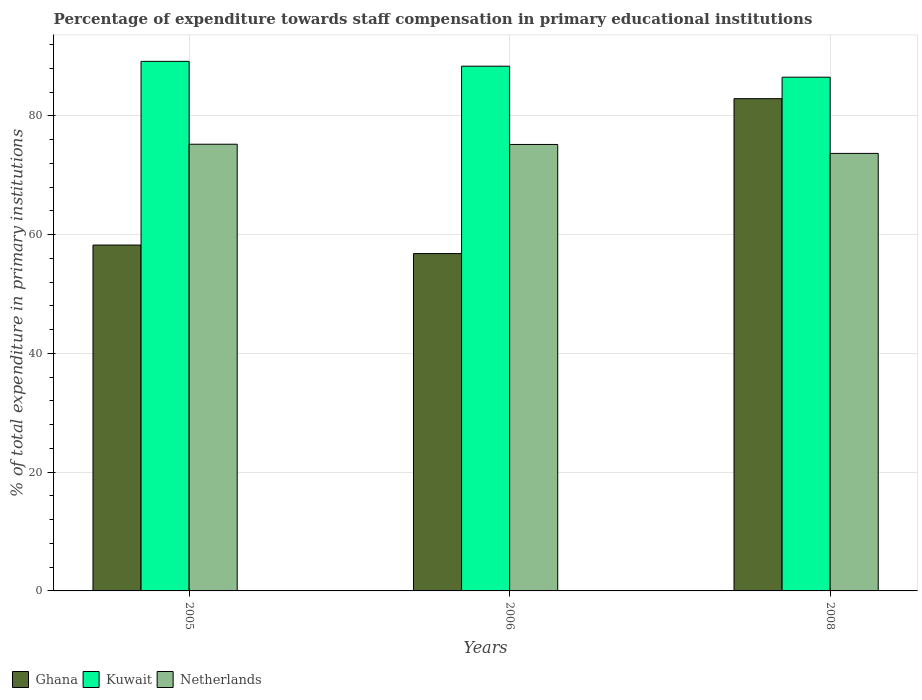How many different coloured bars are there?
Provide a succinct answer. 3. How many groups of bars are there?
Keep it short and to the point. 3. Are the number of bars on each tick of the X-axis equal?
Offer a terse response. Yes. How many bars are there on the 1st tick from the left?
Provide a short and direct response. 3. What is the percentage of expenditure towards staff compensation in Kuwait in 2006?
Give a very brief answer. 88.37. Across all years, what is the maximum percentage of expenditure towards staff compensation in Ghana?
Your answer should be very brief. 82.9. Across all years, what is the minimum percentage of expenditure towards staff compensation in Netherlands?
Offer a very short reply. 73.68. What is the total percentage of expenditure towards staff compensation in Kuwait in the graph?
Your answer should be compact. 264.07. What is the difference between the percentage of expenditure towards staff compensation in Netherlands in 2005 and that in 2008?
Your response must be concise. 1.54. What is the difference between the percentage of expenditure towards staff compensation in Ghana in 2008 and the percentage of expenditure towards staff compensation in Netherlands in 2005?
Your response must be concise. 7.67. What is the average percentage of expenditure towards staff compensation in Netherlands per year?
Offer a terse response. 74.7. In the year 2006, what is the difference between the percentage of expenditure towards staff compensation in Netherlands and percentage of expenditure towards staff compensation in Ghana?
Keep it short and to the point. 18.38. In how many years, is the percentage of expenditure towards staff compensation in Netherlands greater than 16 %?
Offer a very short reply. 3. What is the ratio of the percentage of expenditure towards staff compensation in Kuwait in 2005 to that in 2008?
Provide a succinct answer. 1.03. Is the percentage of expenditure towards staff compensation in Netherlands in 2005 less than that in 2008?
Ensure brevity in your answer.  No. Is the difference between the percentage of expenditure towards staff compensation in Netherlands in 2005 and 2006 greater than the difference between the percentage of expenditure towards staff compensation in Ghana in 2005 and 2006?
Ensure brevity in your answer.  No. What is the difference between the highest and the second highest percentage of expenditure towards staff compensation in Netherlands?
Provide a succinct answer. 0.04. What is the difference between the highest and the lowest percentage of expenditure towards staff compensation in Netherlands?
Provide a succinct answer. 1.54. In how many years, is the percentage of expenditure towards staff compensation in Kuwait greater than the average percentage of expenditure towards staff compensation in Kuwait taken over all years?
Your answer should be very brief. 2. Is the sum of the percentage of expenditure towards staff compensation in Kuwait in 2005 and 2008 greater than the maximum percentage of expenditure towards staff compensation in Ghana across all years?
Your response must be concise. Yes. Is it the case that in every year, the sum of the percentage of expenditure towards staff compensation in Kuwait and percentage of expenditure towards staff compensation in Ghana is greater than the percentage of expenditure towards staff compensation in Netherlands?
Your answer should be very brief. Yes. How many years are there in the graph?
Keep it short and to the point. 3. Are the values on the major ticks of Y-axis written in scientific E-notation?
Ensure brevity in your answer.  No. Does the graph contain any zero values?
Your answer should be compact. No. How are the legend labels stacked?
Your response must be concise. Horizontal. What is the title of the graph?
Make the answer very short. Percentage of expenditure towards staff compensation in primary educational institutions. Does "Jamaica" appear as one of the legend labels in the graph?
Make the answer very short. No. What is the label or title of the X-axis?
Keep it short and to the point. Years. What is the label or title of the Y-axis?
Your answer should be compact. % of total expenditure in primary institutions. What is the % of total expenditure in primary institutions in Ghana in 2005?
Offer a terse response. 58.25. What is the % of total expenditure in primary institutions of Kuwait in 2005?
Your answer should be very brief. 89.19. What is the % of total expenditure in primary institutions in Netherlands in 2005?
Your answer should be compact. 75.23. What is the % of total expenditure in primary institutions in Ghana in 2006?
Offer a terse response. 56.81. What is the % of total expenditure in primary institutions of Kuwait in 2006?
Make the answer very short. 88.37. What is the % of total expenditure in primary institutions of Netherlands in 2006?
Your answer should be very brief. 75.19. What is the % of total expenditure in primary institutions of Ghana in 2008?
Your answer should be compact. 82.9. What is the % of total expenditure in primary institutions in Kuwait in 2008?
Ensure brevity in your answer.  86.52. What is the % of total expenditure in primary institutions of Netherlands in 2008?
Give a very brief answer. 73.68. Across all years, what is the maximum % of total expenditure in primary institutions of Ghana?
Offer a terse response. 82.9. Across all years, what is the maximum % of total expenditure in primary institutions in Kuwait?
Offer a terse response. 89.19. Across all years, what is the maximum % of total expenditure in primary institutions of Netherlands?
Your answer should be compact. 75.23. Across all years, what is the minimum % of total expenditure in primary institutions of Ghana?
Your response must be concise. 56.81. Across all years, what is the minimum % of total expenditure in primary institutions in Kuwait?
Offer a terse response. 86.52. Across all years, what is the minimum % of total expenditure in primary institutions in Netherlands?
Keep it short and to the point. 73.68. What is the total % of total expenditure in primary institutions of Ghana in the graph?
Provide a short and direct response. 197.96. What is the total % of total expenditure in primary institutions of Kuwait in the graph?
Provide a short and direct response. 264.07. What is the total % of total expenditure in primary institutions of Netherlands in the graph?
Make the answer very short. 224.1. What is the difference between the % of total expenditure in primary institutions in Ghana in 2005 and that in 2006?
Ensure brevity in your answer.  1.44. What is the difference between the % of total expenditure in primary institutions in Kuwait in 2005 and that in 2006?
Keep it short and to the point. 0.81. What is the difference between the % of total expenditure in primary institutions in Netherlands in 2005 and that in 2006?
Give a very brief answer. 0.04. What is the difference between the % of total expenditure in primary institutions in Ghana in 2005 and that in 2008?
Offer a very short reply. -24.65. What is the difference between the % of total expenditure in primary institutions in Kuwait in 2005 and that in 2008?
Your answer should be very brief. 2.67. What is the difference between the % of total expenditure in primary institutions in Netherlands in 2005 and that in 2008?
Provide a succinct answer. 1.54. What is the difference between the % of total expenditure in primary institutions in Ghana in 2006 and that in 2008?
Make the answer very short. -26.09. What is the difference between the % of total expenditure in primary institutions in Kuwait in 2006 and that in 2008?
Provide a short and direct response. 1.85. What is the difference between the % of total expenditure in primary institutions in Netherlands in 2006 and that in 2008?
Provide a short and direct response. 1.5. What is the difference between the % of total expenditure in primary institutions of Ghana in 2005 and the % of total expenditure in primary institutions of Kuwait in 2006?
Give a very brief answer. -30.12. What is the difference between the % of total expenditure in primary institutions in Ghana in 2005 and the % of total expenditure in primary institutions in Netherlands in 2006?
Offer a terse response. -16.94. What is the difference between the % of total expenditure in primary institutions of Kuwait in 2005 and the % of total expenditure in primary institutions of Netherlands in 2006?
Your answer should be compact. 14. What is the difference between the % of total expenditure in primary institutions in Ghana in 2005 and the % of total expenditure in primary institutions in Kuwait in 2008?
Your answer should be compact. -28.27. What is the difference between the % of total expenditure in primary institutions of Ghana in 2005 and the % of total expenditure in primary institutions of Netherlands in 2008?
Your answer should be compact. -15.44. What is the difference between the % of total expenditure in primary institutions of Kuwait in 2005 and the % of total expenditure in primary institutions of Netherlands in 2008?
Offer a very short reply. 15.5. What is the difference between the % of total expenditure in primary institutions in Ghana in 2006 and the % of total expenditure in primary institutions in Kuwait in 2008?
Offer a very short reply. -29.71. What is the difference between the % of total expenditure in primary institutions in Ghana in 2006 and the % of total expenditure in primary institutions in Netherlands in 2008?
Keep it short and to the point. -16.87. What is the difference between the % of total expenditure in primary institutions of Kuwait in 2006 and the % of total expenditure in primary institutions of Netherlands in 2008?
Your response must be concise. 14.69. What is the average % of total expenditure in primary institutions of Ghana per year?
Your answer should be very brief. 65.99. What is the average % of total expenditure in primary institutions in Kuwait per year?
Make the answer very short. 88.02. What is the average % of total expenditure in primary institutions of Netherlands per year?
Your answer should be compact. 74.7. In the year 2005, what is the difference between the % of total expenditure in primary institutions of Ghana and % of total expenditure in primary institutions of Kuwait?
Your answer should be compact. -30.94. In the year 2005, what is the difference between the % of total expenditure in primary institutions of Ghana and % of total expenditure in primary institutions of Netherlands?
Give a very brief answer. -16.98. In the year 2005, what is the difference between the % of total expenditure in primary institutions of Kuwait and % of total expenditure in primary institutions of Netherlands?
Keep it short and to the point. 13.96. In the year 2006, what is the difference between the % of total expenditure in primary institutions of Ghana and % of total expenditure in primary institutions of Kuwait?
Keep it short and to the point. -31.56. In the year 2006, what is the difference between the % of total expenditure in primary institutions in Ghana and % of total expenditure in primary institutions in Netherlands?
Ensure brevity in your answer.  -18.38. In the year 2006, what is the difference between the % of total expenditure in primary institutions of Kuwait and % of total expenditure in primary institutions of Netherlands?
Make the answer very short. 13.18. In the year 2008, what is the difference between the % of total expenditure in primary institutions of Ghana and % of total expenditure in primary institutions of Kuwait?
Offer a very short reply. -3.62. In the year 2008, what is the difference between the % of total expenditure in primary institutions in Ghana and % of total expenditure in primary institutions in Netherlands?
Ensure brevity in your answer.  9.22. In the year 2008, what is the difference between the % of total expenditure in primary institutions in Kuwait and % of total expenditure in primary institutions in Netherlands?
Your answer should be very brief. 12.83. What is the ratio of the % of total expenditure in primary institutions in Ghana in 2005 to that in 2006?
Ensure brevity in your answer.  1.03. What is the ratio of the % of total expenditure in primary institutions of Kuwait in 2005 to that in 2006?
Keep it short and to the point. 1.01. What is the ratio of the % of total expenditure in primary institutions in Ghana in 2005 to that in 2008?
Your answer should be compact. 0.7. What is the ratio of the % of total expenditure in primary institutions in Kuwait in 2005 to that in 2008?
Give a very brief answer. 1.03. What is the ratio of the % of total expenditure in primary institutions in Ghana in 2006 to that in 2008?
Ensure brevity in your answer.  0.69. What is the ratio of the % of total expenditure in primary institutions of Kuwait in 2006 to that in 2008?
Provide a short and direct response. 1.02. What is the ratio of the % of total expenditure in primary institutions of Netherlands in 2006 to that in 2008?
Your answer should be compact. 1.02. What is the difference between the highest and the second highest % of total expenditure in primary institutions in Ghana?
Offer a very short reply. 24.65. What is the difference between the highest and the second highest % of total expenditure in primary institutions in Kuwait?
Give a very brief answer. 0.81. What is the difference between the highest and the second highest % of total expenditure in primary institutions in Netherlands?
Offer a very short reply. 0.04. What is the difference between the highest and the lowest % of total expenditure in primary institutions of Ghana?
Provide a succinct answer. 26.09. What is the difference between the highest and the lowest % of total expenditure in primary institutions in Kuwait?
Ensure brevity in your answer.  2.67. What is the difference between the highest and the lowest % of total expenditure in primary institutions in Netherlands?
Make the answer very short. 1.54. 